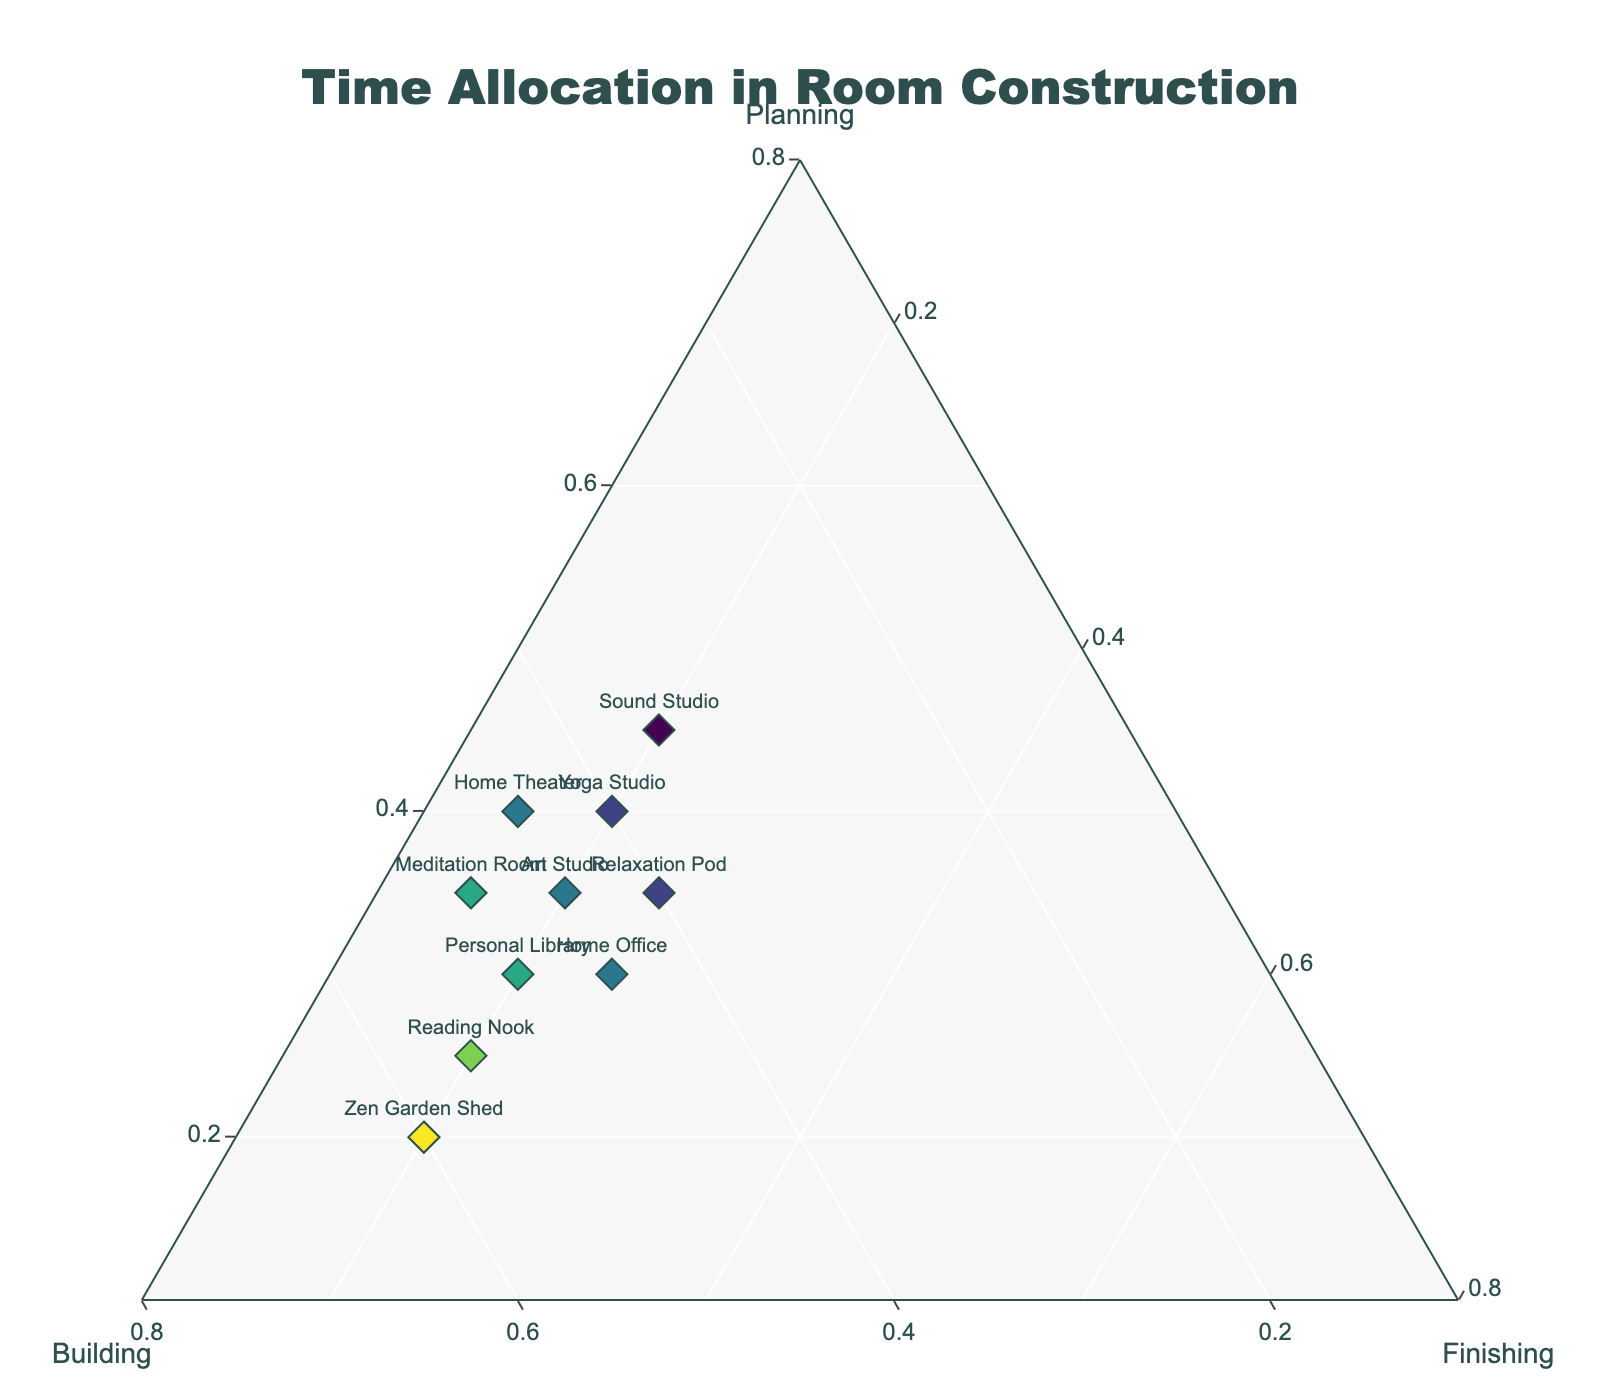What's the title of the plot? The title of the plot is usually displayed at the top center of the figure. It indicates what the plot represents. Here, it names the broad subject of the figure.
Answer: Time Allocation in Room Construction How many projects are displayed in the plot? The plot displays markers for each project. By counting the number of different markers with associated labels, you can find the number of projects. According to the data, there are 10 projects shown.
Answer: 10 For the Meditation Room project, which phase has the highest time allocation? Locate the marker for the Meditation Room and check the ratios for Planning, Building, and Finishing. The one with the highest ratio indicates the phase with the highest time allocation. For the Meditation Room project, Building has the highest allocation at 50%.
Answer: Building Which project allocates the least percentage of time to Planning? Look at all the markers and find the label with the smallest Planning ratio (a-axis). The project with the lowest value here allocates the least time to Planning. According to the data, the Zen Garden Shed has the lowest Planning ratio at 20%.
Answer: Zen Garden Shed For the Sound Studio, what is the combined percentage of time allocated to Planning and Finishing? Find the marker for the Sound Studio and add the Planning and Finishing ratios. Planning is 45% and Finishing is 20%, so their sum is 65%.
Answer: 65% Which project dedicates equal time allocation to Building and Finishing? Look for a marker where the Building ratio equals the Finishing ratio. The only project with these values equal (both at 20%) is the Yoga Studio.
Answer: Yoga Studio Which project spends the highest percentage of time in the Building phase? Identify the marker where the Building ratio (b-axis) is the highest. According to the data, the Zen Garden Shed allocates 60% to Building, the highest among all projects.
Answer: Zen Garden Shed Compare the Planning and Finishing ratios of the Home Theater project. Which is higher and by how much? Find the Home Theater marker and compare the Planning and Finishing ratios. Planning is 40% while Finishing is 15%. Thus, Planning is higher by 25%.
Answer: Planning is higher by 25% Find the average Planning ratio across all projects. Sum all the Planning ratios and divide by the number of projects. The Planning ratios are 35%, 30%, 40%, 25%, 20%, 45%, 30%, 35%, 40%, 35%. Summing these gives 335%, and the average is 335% / 10 = 33.5%.
Answer: 33.5% How does the time allocation for the Art Studio compare to the Personal Library? Check the ratios for both projects. For the Art Studio, they are Planning 35%, Building 45%, Finishing 20%, and for the Personal Library, they are Planning 30%, Building 50%, Finishing 20%. The Building phase allocation is higher for the Personal Library, while the Planning phase allocation is higher for the Art Studio. Both have the same allocation for the Finishing phase.
Answer: Art Studio: higher Planning, Personal Library: higher Building, same Finishing 